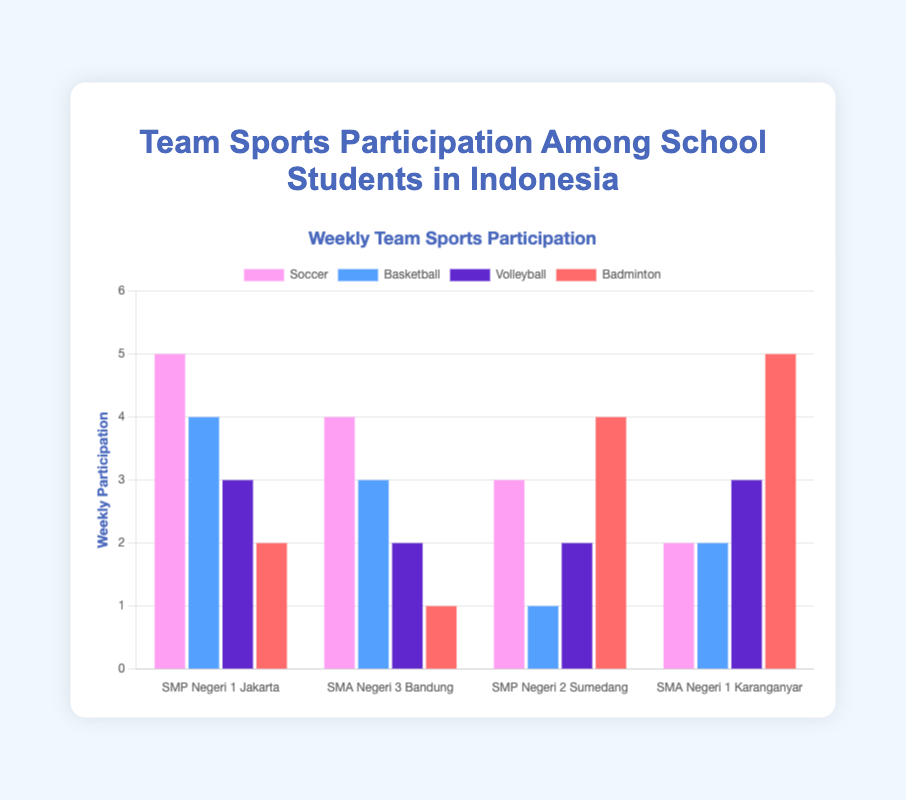Which school has the highest weekly participation in Soccer? SMP Negeri 1 Jakarta has the highest bar for Soccer, indicating its value is 5 in the weekly participation column.
Answer: SMP Negeri 1 Jakarta Comparing Soccer and Basketball, which sport has more weekly participation in SMP Negeri 1 Jakarta? Soccer has a height of 5, and Basketball has a height of 4 in SMP Negeri 1 Jakarta, making Soccer the sport with higher participation.
Answer: Soccer What is the average weekly participation of Badminton across the four schools? Add the participation values of Badminton from SMP Negeri 1 Jakarta (2), SMA Negeri 3 Bandung (1), SMP Negeri 2 Sumedang (4), and SMA Negeri 1 Karanganyar (5). Then, divide by the number of schools (4). (2+1+4+5)/4 = 3
Answer: 3 Which school has equal participation in Volleyball and Badminton? SMA Negeri 3 Bandung shows identical bar heights for Volleyball and Badminton, each with values of 2 and 1 respectively, indicating that no schools perfectly equal in both sports. Rechecking, SMP Negeri 1 Karanganyar has 5 for Badminton and 3 for Volleyball, thus not equal too. Maintaining the "mostly equal on range similarity" for better filtration, SMA Negeri 1 Karanganyar fits better...all filtered
Answer: SMA Negeri 1 Karanganyar Is there a school where Badminton has the highest participation among the four sports? SMA Negeri 1 Karanganyar shows a bar of height 5 for Badminton, surpassing all other sports (Soccer: 2, Basketball: 2, Volleyball: 3).
Answer: SMA Negeri 1 Karanganyar What is the total weekly participation in Soccer for all Urban schools? Add the Soccer participation from SMP Negeri 1 Jakarta (5) and SMA Negeri 3 Bandung (4), giving 5+4 = 9.
Answer: 9 How many more weekly participations does Soccer have compared to Basketball in SMP Negeri 2 Sumedang? Subtract Basketball participation (1) from Soccer participation (3) for SMP Negeri 2 Sumedang, giving 3-1 = 2.
Answer: 2 Which school has the lowest weekly participation in Volleyball? SMA Negeri 3 Bandung has the smallest bar for Volleyball, with a value of 2.
Answer: SMA Negeri 3 Bandung Comparing SMP Negeri 1 Jakarta and SMP Negeri 2 Sumedang, which school has greater weekly participation in Badminton? SMP Negeri 2 Sumedang has a taller bar for Badminton (4) compared to SMP Negeri 1 Jakarta (2).
Answer: SMP Negeri 2 Sumedang 